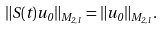<formula> <loc_0><loc_0><loc_500><loc_500>\| S ( t ) u _ { 0 } \| _ { M _ { 2 , 1 } } = \| u _ { 0 } \| _ { M _ { 2 , 1 } } .</formula> 